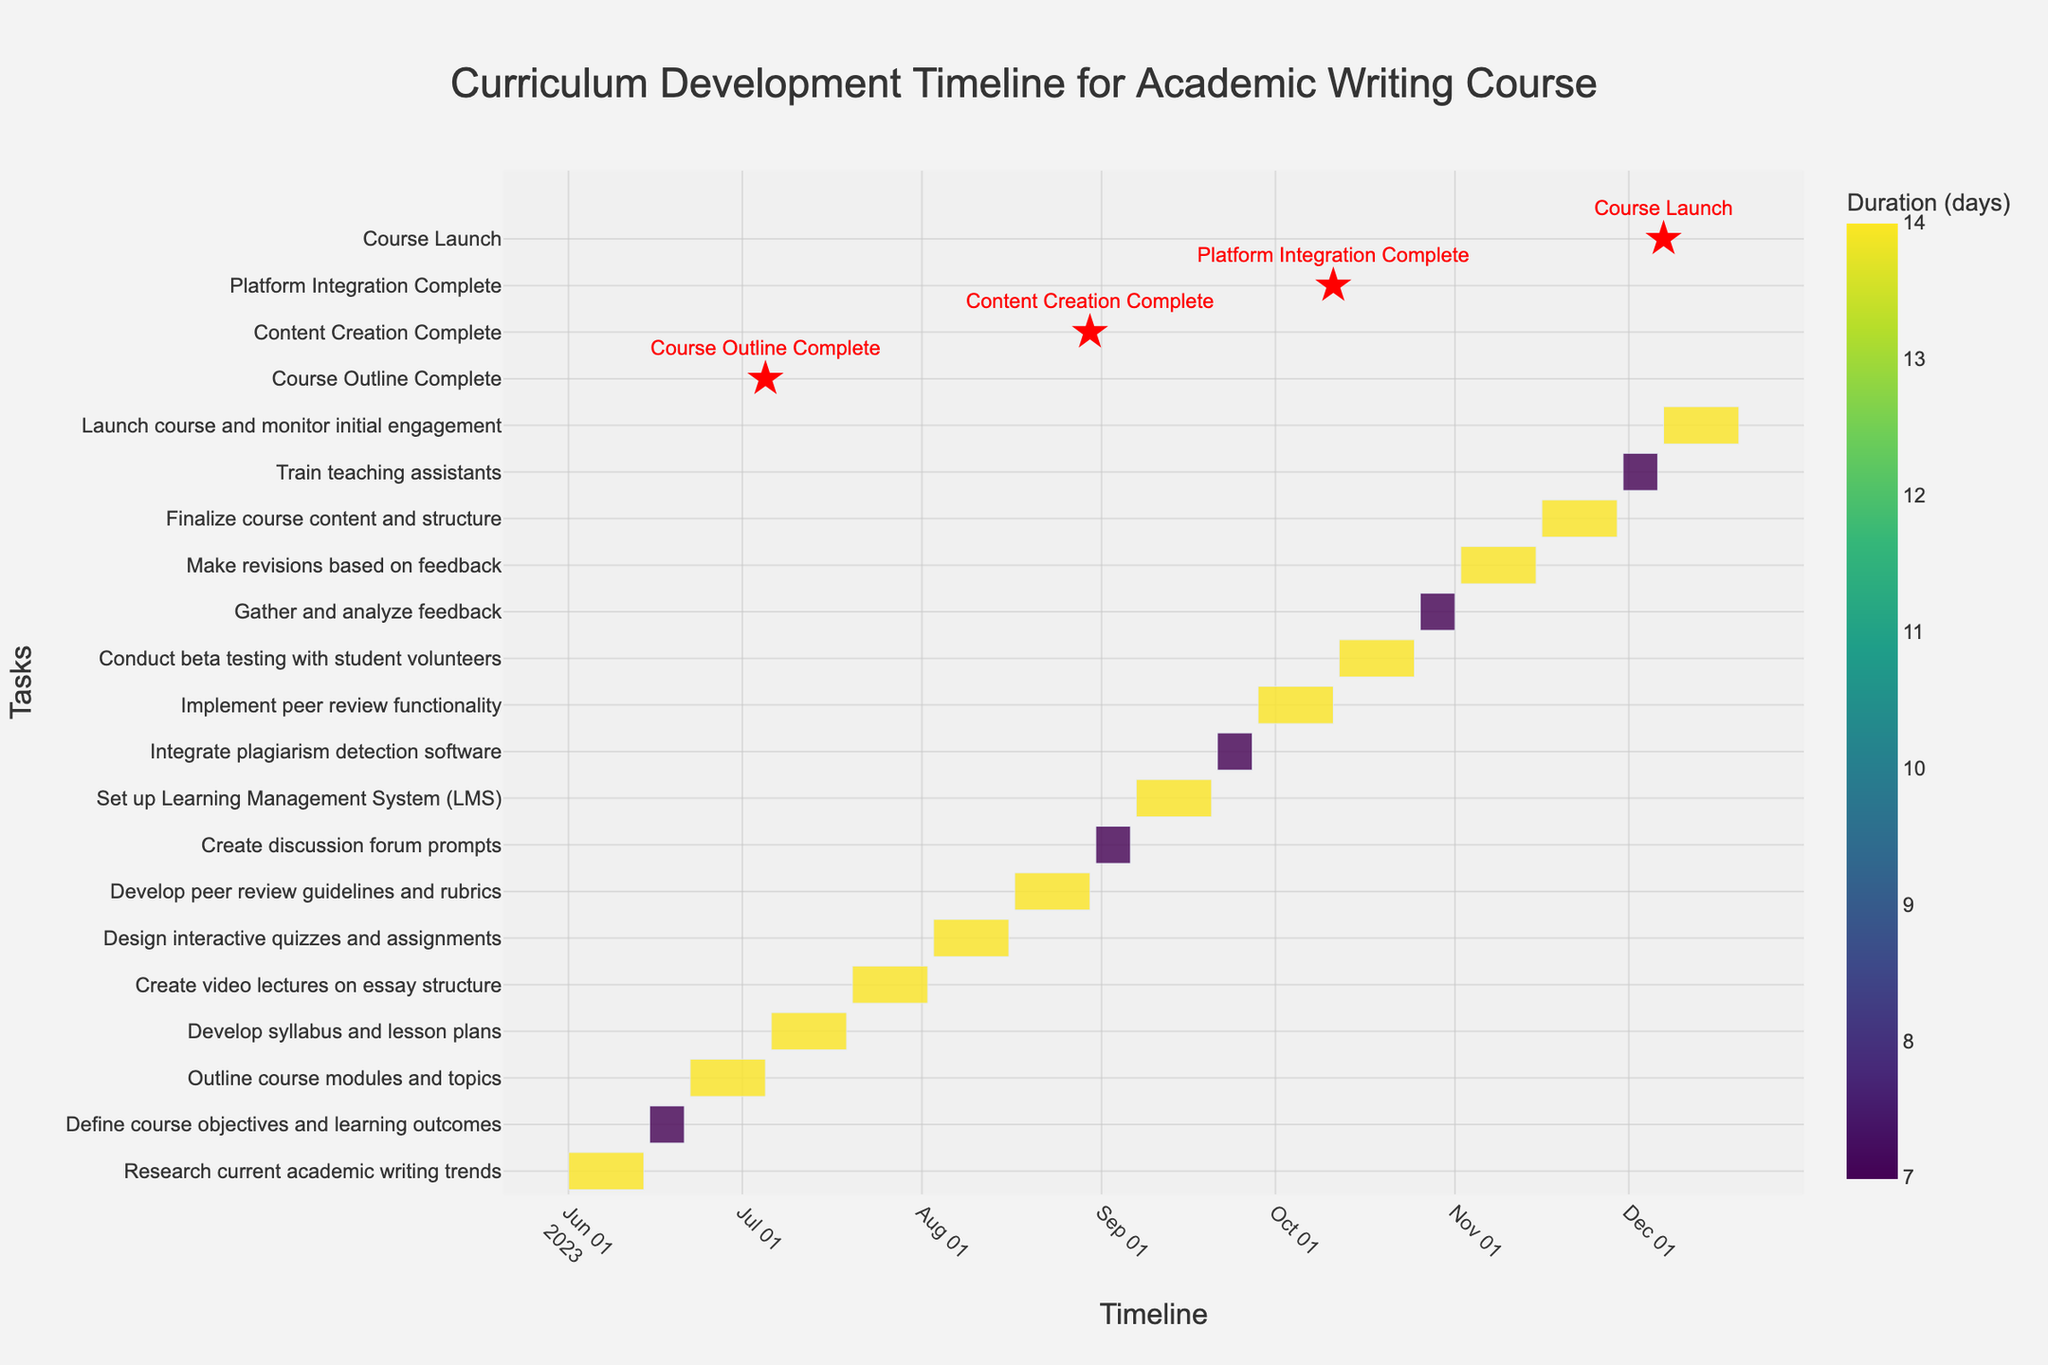How many tasks are listed in the Gantt chart? Count each unique task listed on the y-axis of the Gantt chart.
Answer: 17 What is the overall duration of the entire curriculum development process? The overall duration can be determined by subtracting the start date of the first task from the end date of the last task. The process starts on 2023-06-01 and ends on 2023-12-20, making it about 203 days.
Answer: 203 days Which task has the longest duration? Identify the task with the highest value in the duration column on the Gantt chart.
Answer: Several tasks have the longest duration of 14 days, including "Research current academic writing trends" and others When does the peer review functionality implementation start and end? Locate the task "Implement peer review functionality" on the Gantt chart and read off its start and end dates.
Answer: Start: 2023-09-28, End: 2023-10-11 What are the milestones marked in the Gantt chart? Identify the special markers (stars) used to denote the milestones in the Gantt chart. There are four of them: "Course Outline Complete", "Content Creation Complete", "Platform Integration Complete", and "Course Launch".
Answer: Course Outline Complete, Content Creation Complete, Platform Integration Complete, Course Launch Which task is scheduled to finish on July 5, 2023? Find the task that ends on July 5, 2023, on the x-axis and match it to the corresponding task on the y-axis.
Answer: Outline course modules and topics What is the duration of time between the end of content creation and the start of platform integration? "Content Creation Complete" marks the end of content creation on 2023-08-30. Platform integration starts with "Set up LMS" on 2023-09-07. The duration between these dates is determined by the difference in days.
Answer: 8 days Which tasks overlap with the development of peer review guidelines and rubrics? Check the timeframe of the task "Develop peer review guidelines and rubrics" from 2023-08-17 to 2023-08-30 and identify any tasks that share this time period. "Design interactive quizzes and assignments" (2023-08-03 to 2023-08-16) overlaps by 2 days.
Answer: Design interactive quizzes and assignments When does the course launch in the timeline? Refer to the milestone "Course Launch" marked with a star and its position on the x-axis on the Gantt chart.
Answer: 2023-12-07 How many tasks are scheduled to be completed before September? Identify all tasks that end before September 1, 2023, by checking their end dates. These tasks are: "Research current academic writing trends", "Define course objectives and learning outcomes", "Outline course modules and topics", "Develop syllabus and lesson plans", and "Create video lectures on essay structure".
Answer: 5 tasks 